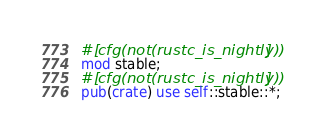Convert code to text. <code><loc_0><loc_0><loc_500><loc_500><_Rust_>
#[cfg(not(rustc_is_nightly))]
mod stable;
#[cfg(not(rustc_is_nightly))]
pub(crate) use self::stable::*;
</code> 